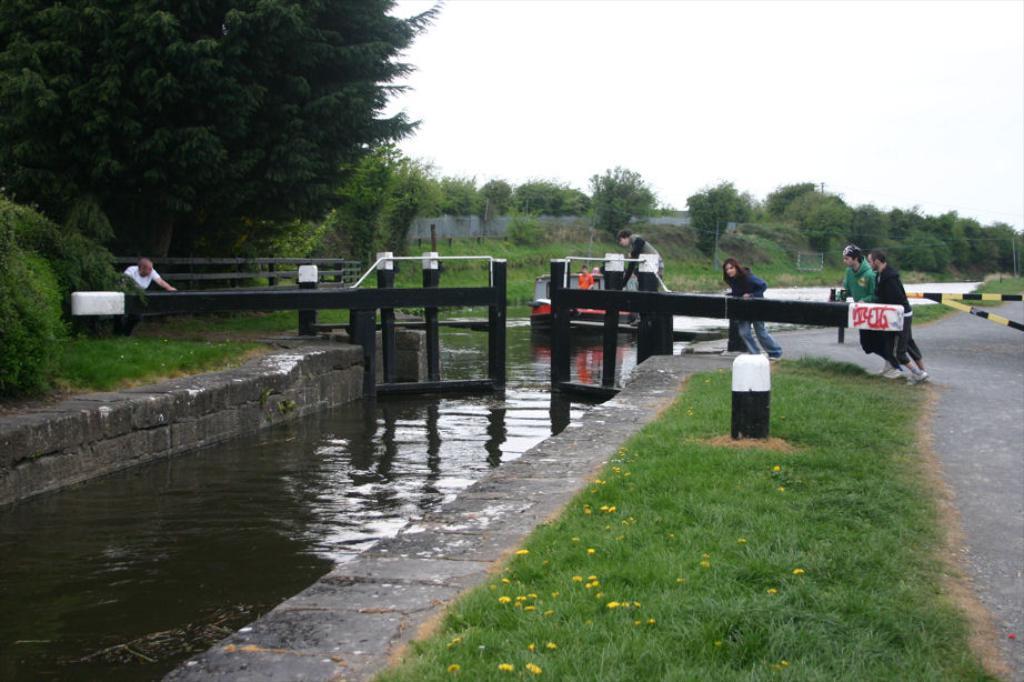Can you describe this image briefly? In this picture we can see flowers, grass, people on the road, here we can see a boat, water, fence, rods and in the background we can see a wall, trees, sky. 